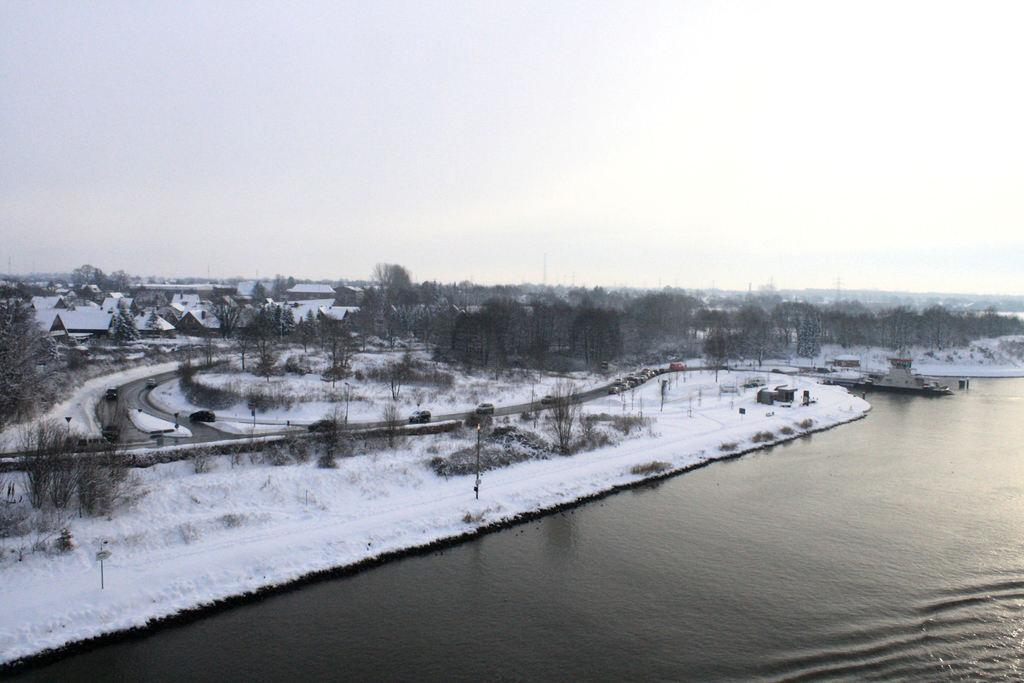What is the primary element present in the image? There is water in the image. What type of terrain is near the water? There is a snow surface near the water. What type of man-made structures can be seen in the image? There are roads visible in the image. What type of vegetation is present in the image? There are trees in the image. What can be seen in the background of the image? The sky is visible in the background of the image. How many roses are floating on the water in the image? There are no roses present in the image; it features water, a snow surface, roads, trees, and a sky background. Can you see a duck swimming in the water in the image? There is no duck present in the image; it only features water, a snow surface, roads, trees, and a sky background. 